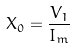<formula> <loc_0><loc_0><loc_500><loc_500>X _ { 0 } = \frac { V _ { 1 } } { I _ { m } }</formula> 